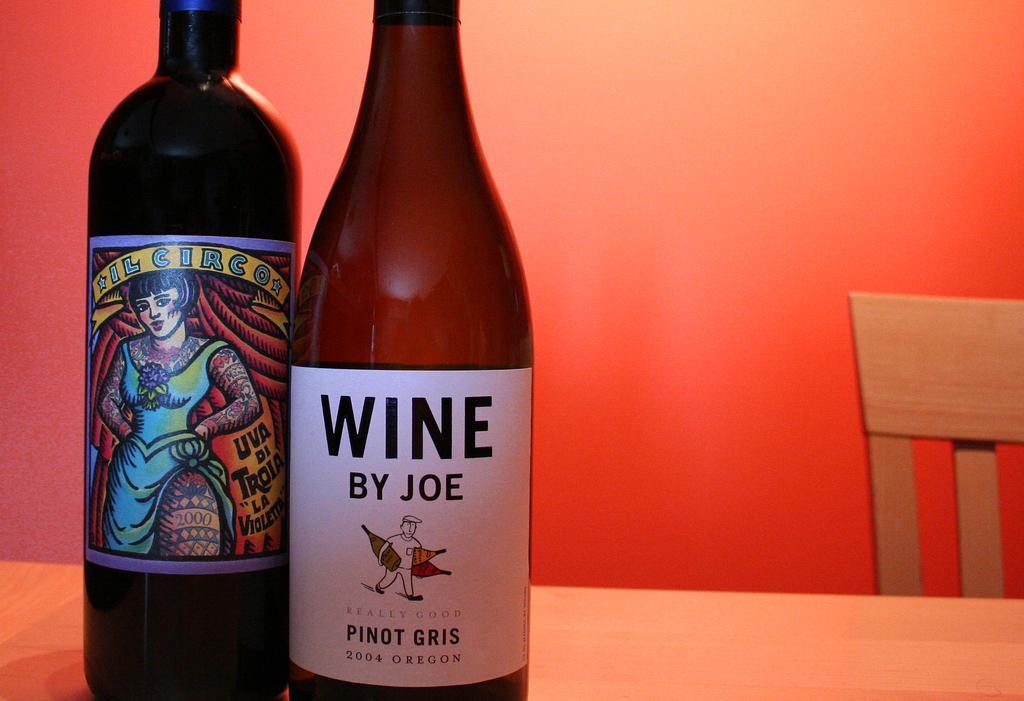<image>
Give a short and clear explanation of the subsequent image. Two wind bottles sit side by side, on with a colorful label, the other with a plainer label for Wine by Joe. 